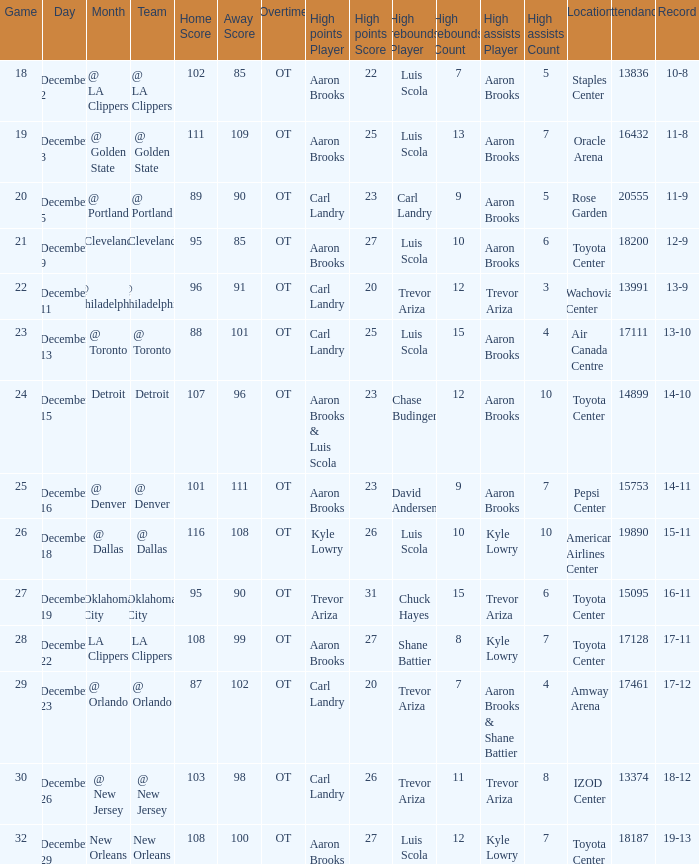Where was the game in which Carl Landry (25) did the most high points played? Air Canada Centre 17111. 